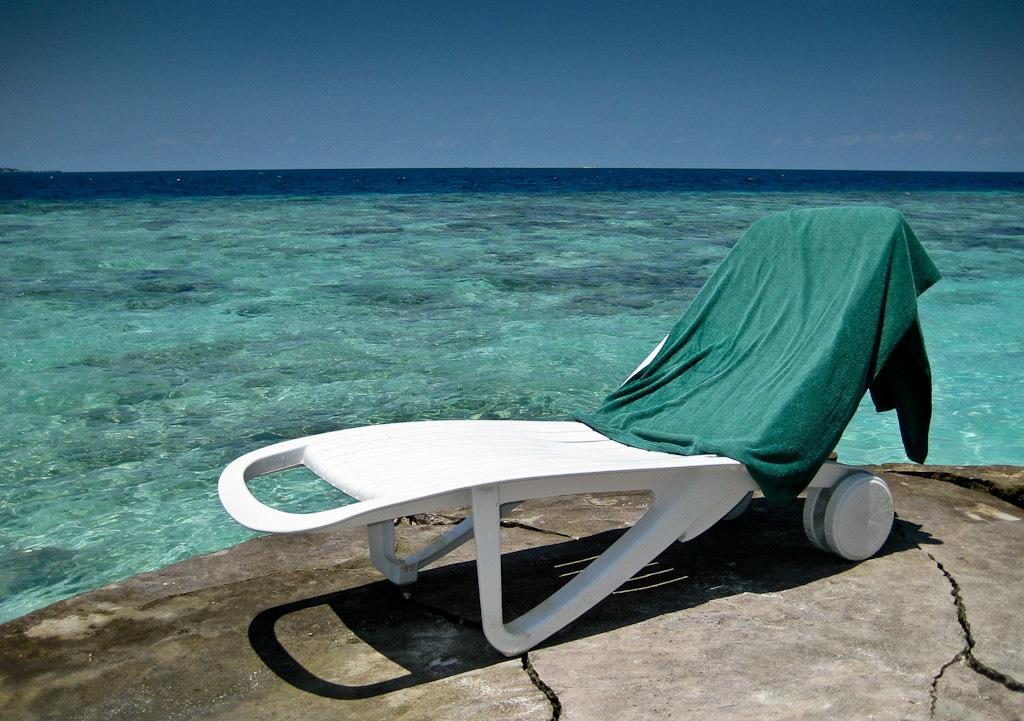What is on the chair in the image? There is cloth on a chair in the image. What can be seen in the middle of the image? There is a sea in the middle of the image. What is visible at the top of the image? The sky is visible at the top of the image. What type of animal can be seen swimming in the sea in the image? There is no animal visible in the sea in the image. How much debt is represented by the cloth on the chair in the image? The cloth on the chair does not represent any debt; it is simply a piece of cloth on a chair. 